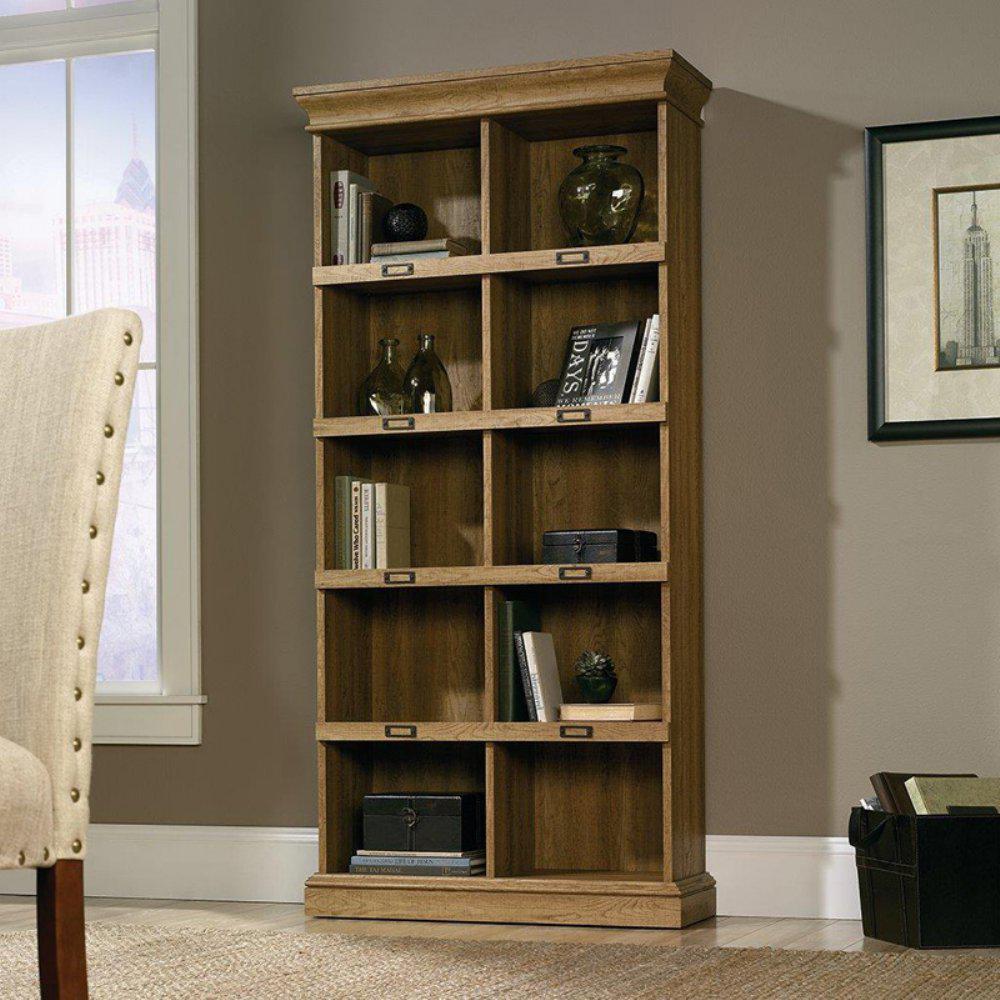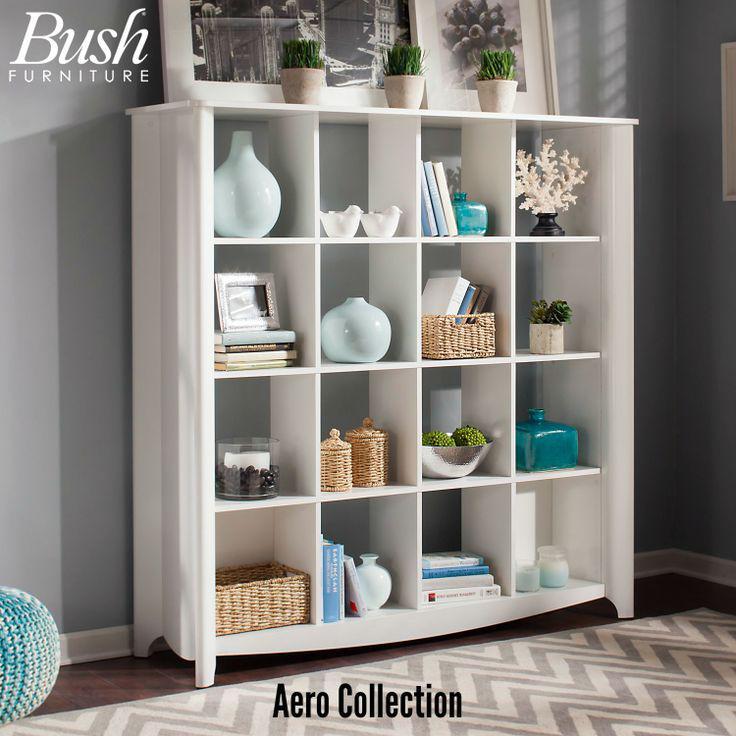The first image is the image on the left, the second image is the image on the right. Assess this claim about the two images: "An image shows a four-shelf cabinet with a blue and white color scheme and plank wood back.". Correct or not? Answer yes or no. No. The first image is the image on the left, the second image is the image on the right. Considering the images on both sides, is "One of the images contains a book shelf that is blue and white." valid? Answer yes or no. No. 